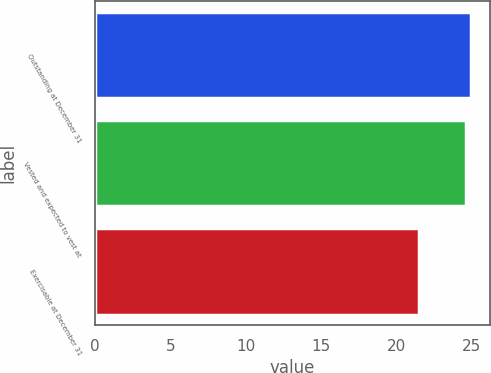Convert chart to OTSL. <chart><loc_0><loc_0><loc_500><loc_500><bar_chart><fcel>Outstanding at December 31<fcel>Vested and expected to vest at<fcel>Exercisable at December 31<nl><fcel>24.95<fcel>24.61<fcel>21.52<nl></chart> 